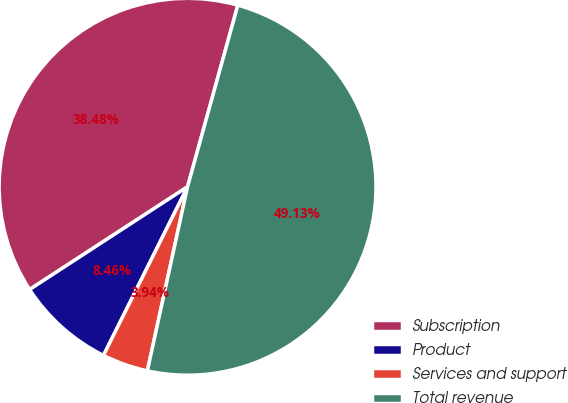<chart> <loc_0><loc_0><loc_500><loc_500><pie_chart><fcel>Subscription<fcel>Product<fcel>Services and support<fcel>Total revenue<nl><fcel>38.48%<fcel>8.46%<fcel>3.94%<fcel>49.13%<nl></chart> 